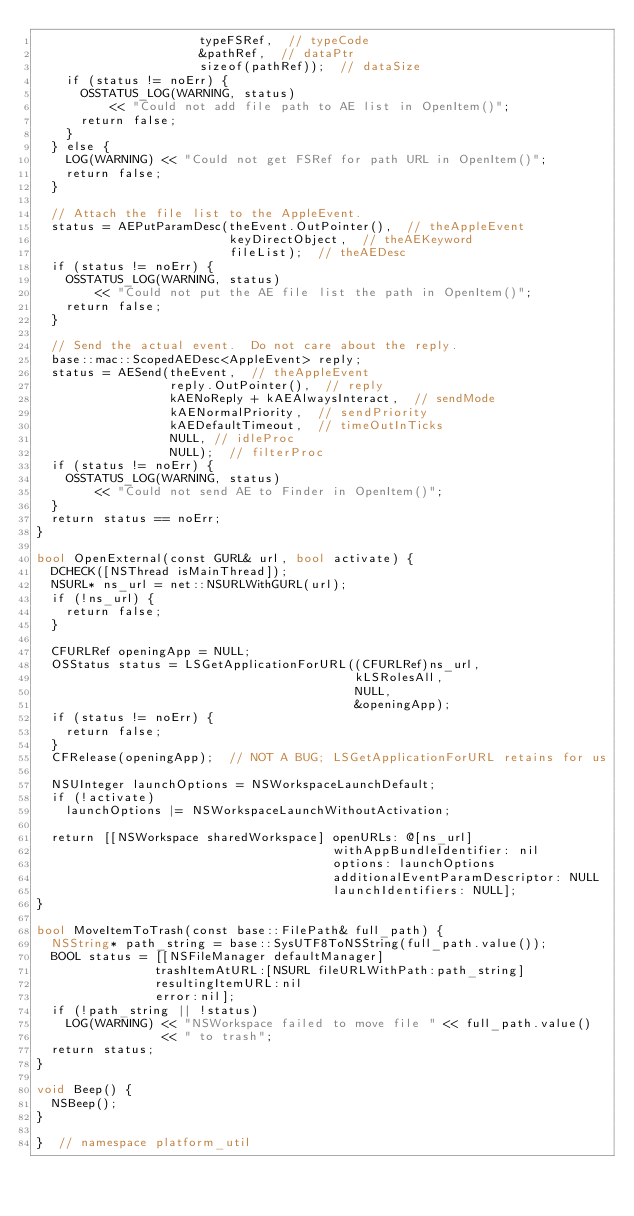Convert code to text. <code><loc_0><loc_0><loc_500><loc_500><_ObjectiveC_>                      typeFSRef,  // typeCode
                      &pathRef,  // dataPtr
                      sizeof(pathRef));  // dataSize
    if (status != noErr) {
      OSSTATUS_LOG(WARNING, status)
          << "Could not add file path to AE list in OpenItem()";
      return false;
    }
  } else {
    LOG(WARNING) << "Could not get FSRef for path URL in OpenItem()";
    return false;
  }

  // Attach the file list to the AppleEvent.
  status = AEPutParamDesc(theEvent.OutPointer(),  // theAppleEvent
                          keyDirectObject,  // theAEKeyword
                          fileList);  // theAEDesc
  if (status != noErr) {
    OSSTATUS_LOG(WARNING, status)
        << "Could not put the AE file list the path in OpenItem()";
    return false;
  }

  // Send the actual event.  Do not care about the reply.
  base::mac::ScopedAEDesc<AppleEvent> reply;
  status = AESend(theEvent,  // theAppleEvent
                  reply.OutPointer(),  // reply
                  kAENoReply + kAEAlwaysInteract,  // sendMode
                  kAENormalPriority,  // sendPriority
                  kAEDefaultTimeout,  // timeOutInTicks
                  NULL, // idleProc
                  NULL);  // filterProc
  if (status != noErr) {
    OSSTATUS_LOG(WARNING, status)
        << "Could not send AE to Finder in OpenItem()";
  }
  return status == noErr;
}

bool OpenExternal(const GURL& url, bool activate) {
  DCHECK([NSThread isMainThread]);
  NSURL* ns_url = net::NSURLWithGURL(url);
  if (!ns_url) {
    return false;
  }

  CFURLRef openingApp = NULL;
  OSStatus status = LSGetApplicationForURL((CFURLRef)ns_url,
                                           kLSRolesAll,
                                           NULL,
                                           &openingApp);
  if (status != noErr) {
    return false;
  }
  CFRelease(openingApp);  // NOT A BUG; LSGetApplicationForURL retains for us

  NSUInteger launchOptions = NSWorkspaceLaunchDefault;
  if (!activate)
    launchOptions |= NSWorkspaceLaunchWithoutActivation;

  return [[NSWorkspace sharedWorkspace] openURLs: @[ns_url]
                                        withAppBundleIdentifier: nil
                                        options: launchOptions
                                        additionalEventParamDescriptor: NULL
                                        launchIdentifiers: NULL];
}

bool MoveItemToTrash(const base::FilePath& full_path) {
  NSString* path_string = base::SysUTF8ToNSString(full_path.value());
  BOOL status = [[NSFileManager defaultManager]
                trashItemAtURL:[NSURL fileURLWithPath:path_string]
                resultingItemURL:nil
                error:nil];
  if (!path_string || !status)
    LOG(WARNING) << "NSWorkspace failed to move file " << full_path.value()
                 << " to trash";
  return status;
}

void Beep() {
  NSBeep();
}

}  // namespace platform_util
</code> 